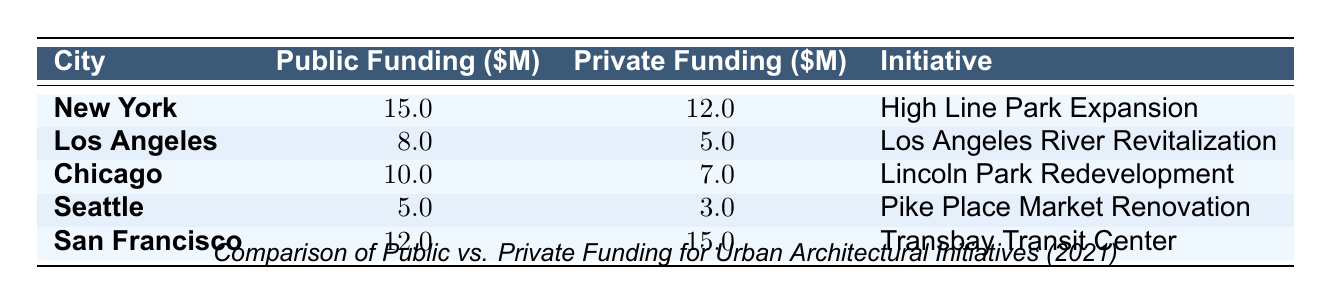What city received the highest public funding for urban architectural initiatives in 2021? The table shows that New York received the highest public funding amounting to $15 million.
Answer: New York What was the total private funding for the initiatives listed in the table? To find the total private funding, add the private funding amounts: 12 + 5 + 7 + 3 + 15 = 42 million dollars.
Answer: 42 million Did Seattle receive more public funding than Chicago? The table indicates Seattle received $5 million in public funding, while Chicago received $10 million, so Seattle did not receive more public funding than Chicago.
Answer: No Which initiative had the lowest private funding, and what was that amount? Looking at the private funding amounts, Pike Place Market Renovation in Seattle had the lowest amount at $3 million.
Answer: Pike Place Market Renovation, $3 million What is the difference between the total public funding in San Francisco and Los Angeles? The public funding for San Francisco is $12 million, while for Los Angeles it is $8 million. The difference is 12 - 8 = $4 million.
Answer: $4 million Which city had a higher ratio of private funding to public funding, Chicago or Seattle? To determine the ratio, divide private funding by public funding: Chicago has 7/10 = 0.7, while Seattle has 3/5 = 0.6. Chicago's ratio is higher since 0.7 > 0.6.
Answer: Chicago What percentage of the total funding (public + private) did the High Line Park Expansion receive from public sources? The total funding for the High Line Park Expansion is 15 + 12 = 27 million. The public funding is 15 million, so the percentage is (15/27) * 100 ≈ 55.56%.
Answer: Approximately 55.56% Which initiative had the greatest difference between public and private funding? Calculate the differences: High Line Park Expansion (3M), River Revitalization (3M), Lincoln Park Redevelopment (3M), Pike Place Market Renovation (2M), Transbay Transit Center (3M). The greatest difference is 3 million for multiple initiatives including Transbay Transit Center.
Answer: 3 million In total, how much public funding was awarded to initiatives located in cities with private funding greater than public funding? The cities with higher private funding than public are San Francisco (12M public, 15M private) and New York (15M public, 12M private). The total public funding from these cities is 12 + 15 = 27 million.
Answer: 27 million Was the combined funding for San Francisco's initiative greater than that of New York's? San Francisco's Transbay Transit Center received 12 + 15 = 27 million in total funding, while New York's High Line Park Expansion received 15 + 12 = 27 million. Both amounts are equal.
Answer: Yes, they are equal 